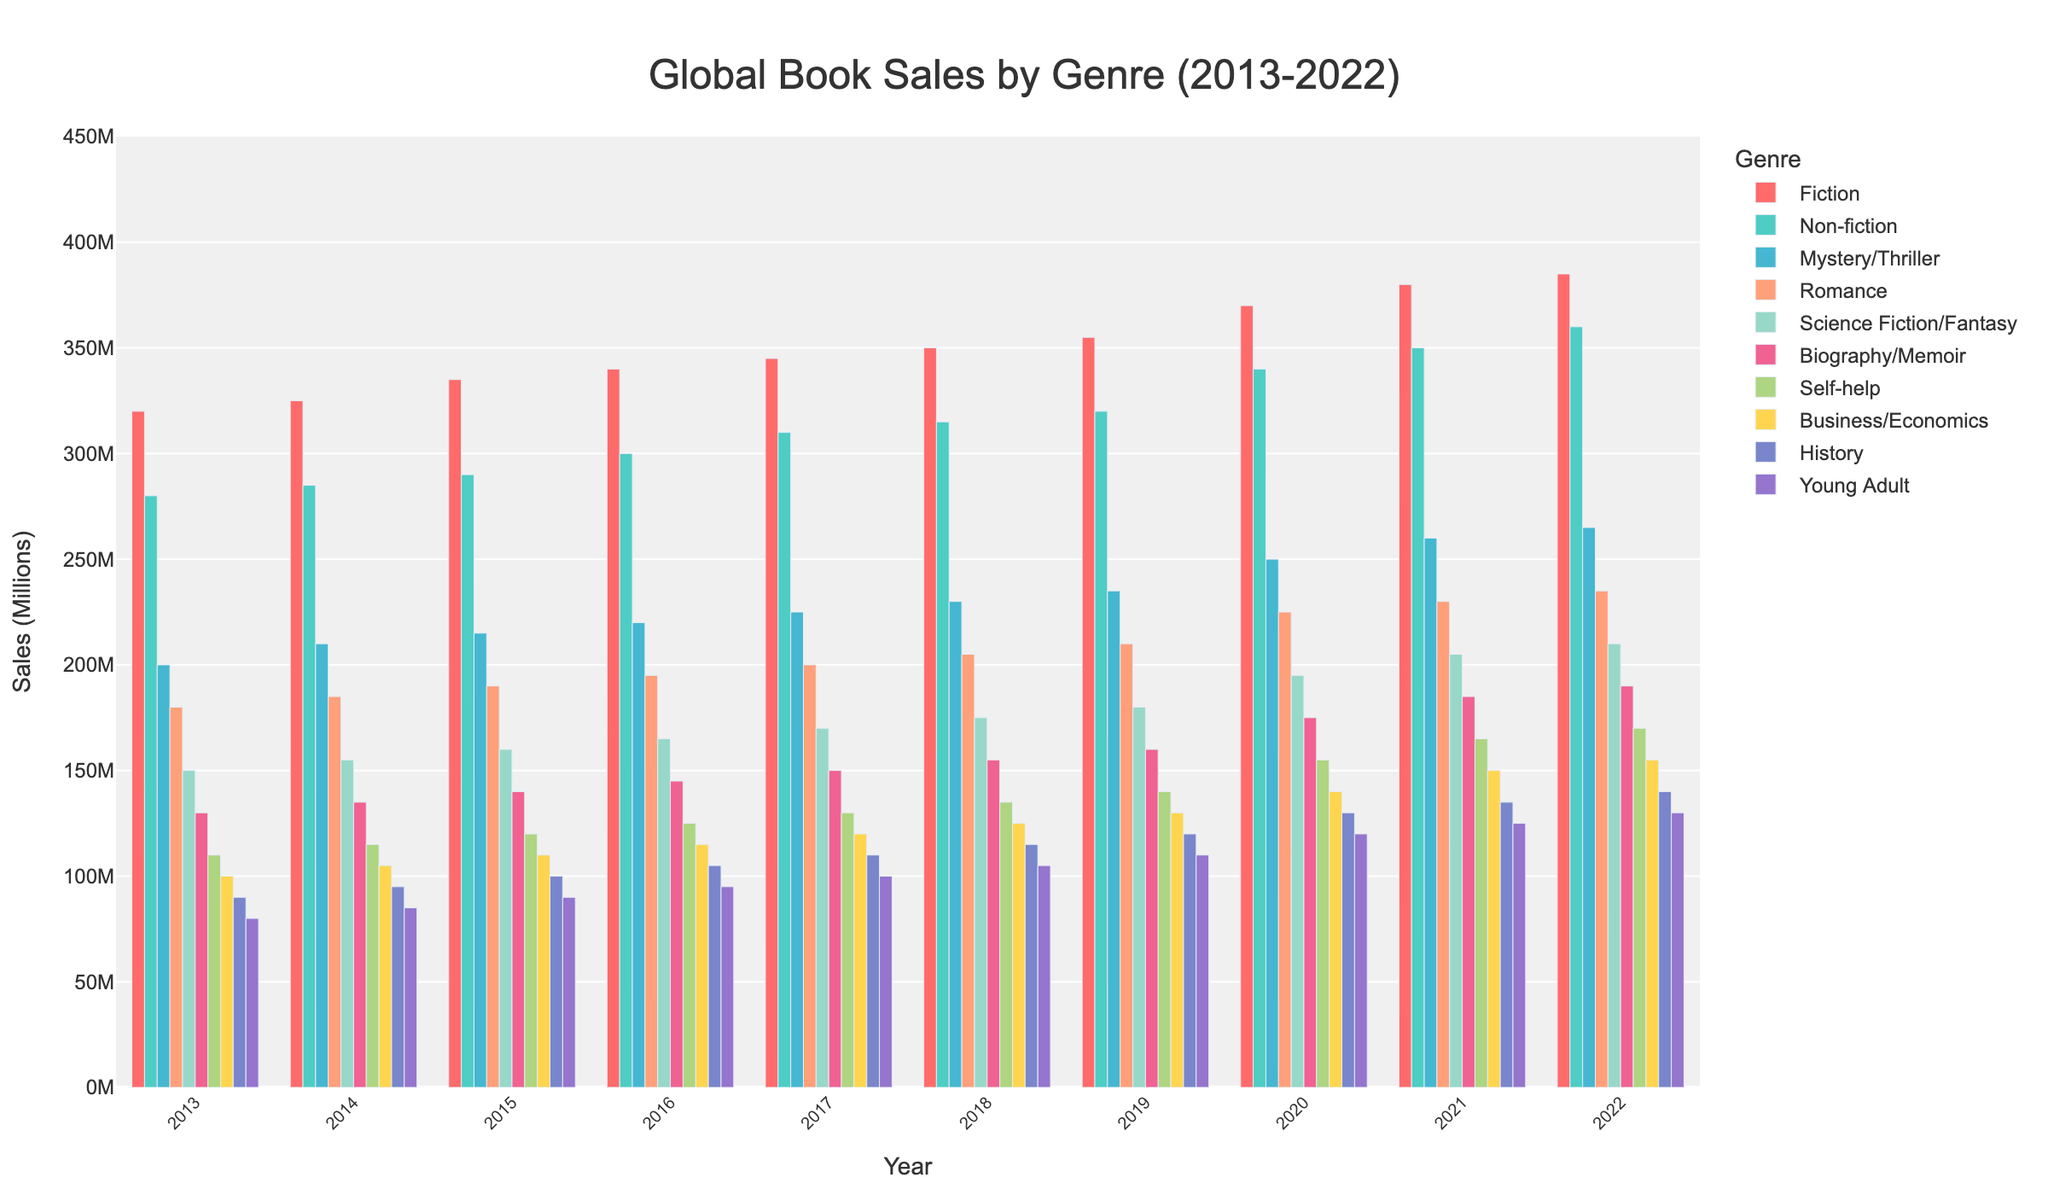Which genre had the highest sales in 2022? Look at the bar heights for 2022 and compare them. Fiction has the tallest bar.
Answer: Fiction How did the sales of Mystery/Thriller change from 2013 to 2022? Subtract the 2013 value from the 2022 value for Mystery/Thriller: 265 - 200 = 65.
Answer: Increased by 65 What is the average sales figure for Non-fiction from 2013 to 2022? Sum the sales figures for Non-fiction from 2013 to 2022 and then divide by the number of years. (280+285+290+300+310+315+320+340+350+360)/10 = 315
Answer: 315 Which genres saw an increase in sales from 2021 to 2022? Identify the genres where the bar height for 2022 is taller than for 2021. All genres saw an increase.
Answer: All genres Compare the sales trends for Romance and Science Fiction/Fantasy from 2013 to 2022. Both genres have increasing trends. Science Fiction/Fantasy had lower initial sales but saw a consistent increase, similar to Romance.
Answer: Both increased Which two genres had the closest sales figures in 2022? Compare the bar heights for 2022 and identify the closest ones. Biography/Memoir (190) and Self-help (170) are closest.
Answer: Biography/Memoir and Self-help What was the total sales of Fiction and Non-fiction in 2017? Sum the sales of Fiction and Non-fiction for 2017. 345+310=655
Answer: 655 How did the sales of Young Adult change over the decade? Subtract the 2013 value from the 2022 value for Young Adult: 130 - 80 = 50.
Answer: Increased by 50 Does the color scheme help in distinguishing between the different genres? Yes, different colors for each genre make it easier to differentiate between them visually.
Answer: Yes Which genre showed the least amount of growth from 2013 to 2022? Compare the total growth for each genre by subtracting 2013 values from 2022 values. Young Adult's growth is 50, which is the least among all.
Answer: Young Adult 